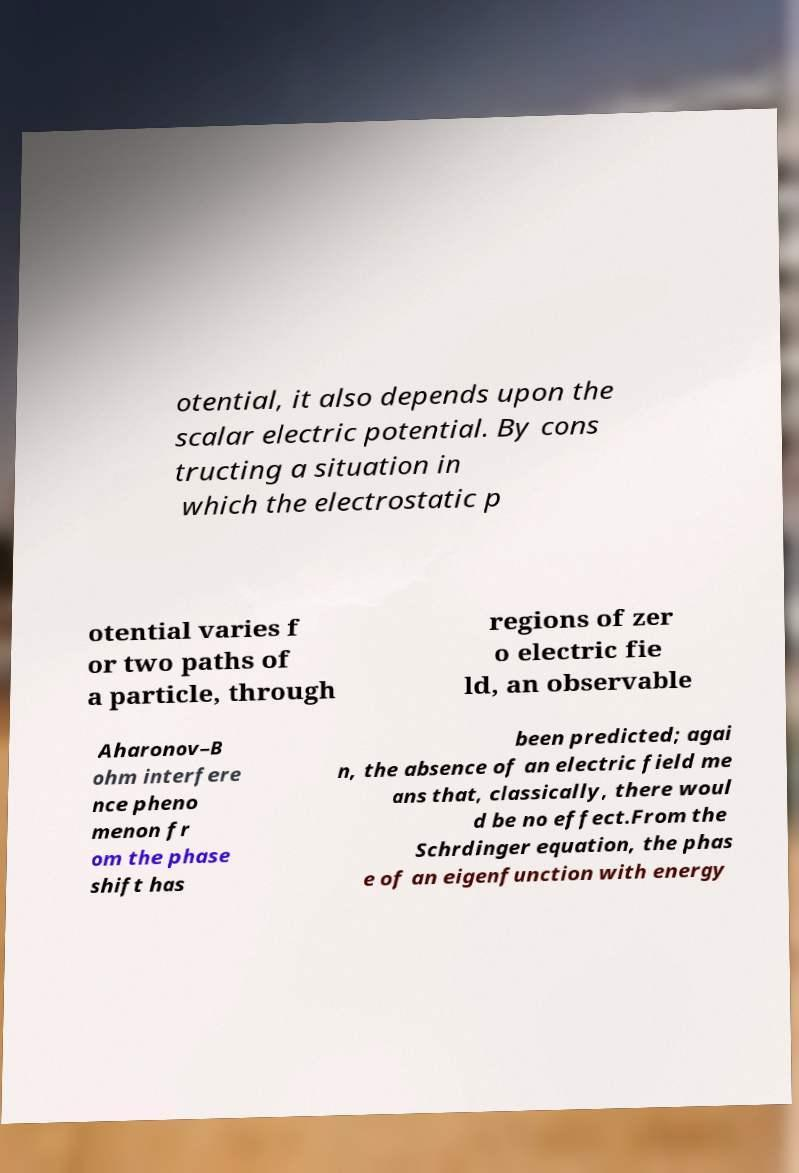For documentation purposes, I need the text within this image transcribed. Could you provide that? otential, it also depends upon the scalar electric potential. By cons tructing a situation in which the electrostatic p otential varies f or two paths of a particle, through regions of zer o electric fie ld, an observable Aharonov–B ohm interfere nce pheno menon fr om the phase shift has been predicted; agai n, the absence of an electric field me ans that, classically, there woul d be no effect.From the Schrdinger equation, the phas e of an eigenfunction with energy 